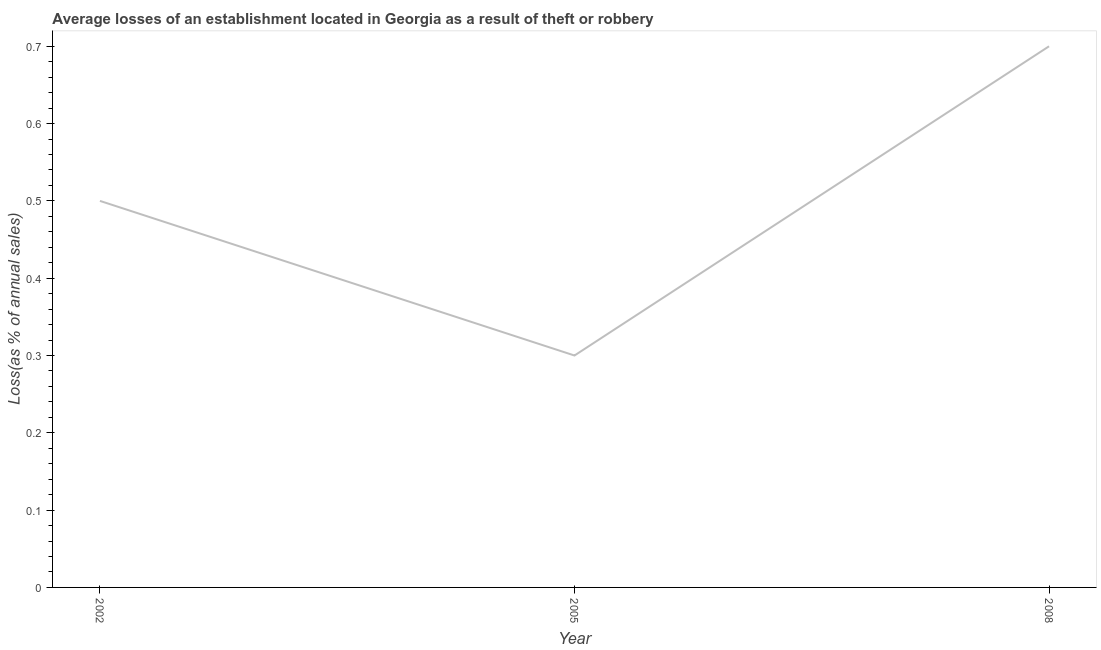What is the losses due to theft in 2005?
Offer a very short reply. 0.3. In which year was the losses due to theft minimum?
Provide a short and direct response. 2005. What is the average losses due to theft per year?
Your answer should be very brief. 0.5. What is the median losses due to theft?
Make the answer very short. 0.5. What is the ratio of the losses due to theft in 2002 to that in 2008?
Give a very brief answer. 0.71. Is the losses due to theft in 2002 less than that in 2005?
Make the answer very short. No. Is the difference between the losses due to theft in 2005 and 2008 greater than the difference between any two years?
Give a very brief answer. Yes. What is the difference between the highest and the second highest losses due to theft?
Make the answer very short. 0.2. Is the sum of the losses due to theft in 2005 and 2008 greater than the maximum losses due to theft across all years?
Offer a very short reply. Yes. What is the difference between the highest and the lowest losses due to theft?
Ensure brevity in your answer.  0.4. In how many years, is the losses due to theft greater than the average losses due to theft taken over all years?
Offer a terse response. 1. How many lines are there?
Provide a short and direct response. 1. Does the graph contain any zero values?
Your response must be concise. No. What is the title of the graph?
Your answer should be compact. Average losses of an establishment located in Georgia as a result of theft or robbery. What is the label or title of the Y-axis?
Ensure brevity in your answer.  Loss(as % of annual sales). What is the Loss(as % of annual sales) of 2005?
Give a very brief answer. 0.3. What is the Loss(as % of annual sales) of 2008?
Your answer should be compact. 0.7. What is the difference between the Loss(as % of annual sales) in 2002 and 2005?
Provide a succinct answer. 0.2. What is the difference between the Loss(as % of annual sales) in 2005 and 2008?
Give a very brief answer. -0.4. What is the ratio of the Loss(as % of annual sales) in 2002 to that in 2005?
Provide a short and direct response. 1.67. What is the ratio of the Loss(as % of annual sales) in 2002 to that in 2008?
Your answer should be compact. 0.71. What is the ratio of the Loss(as % of annual sales) in 2005 to that in 2008?
Provide a short and direct response. 0.43. 